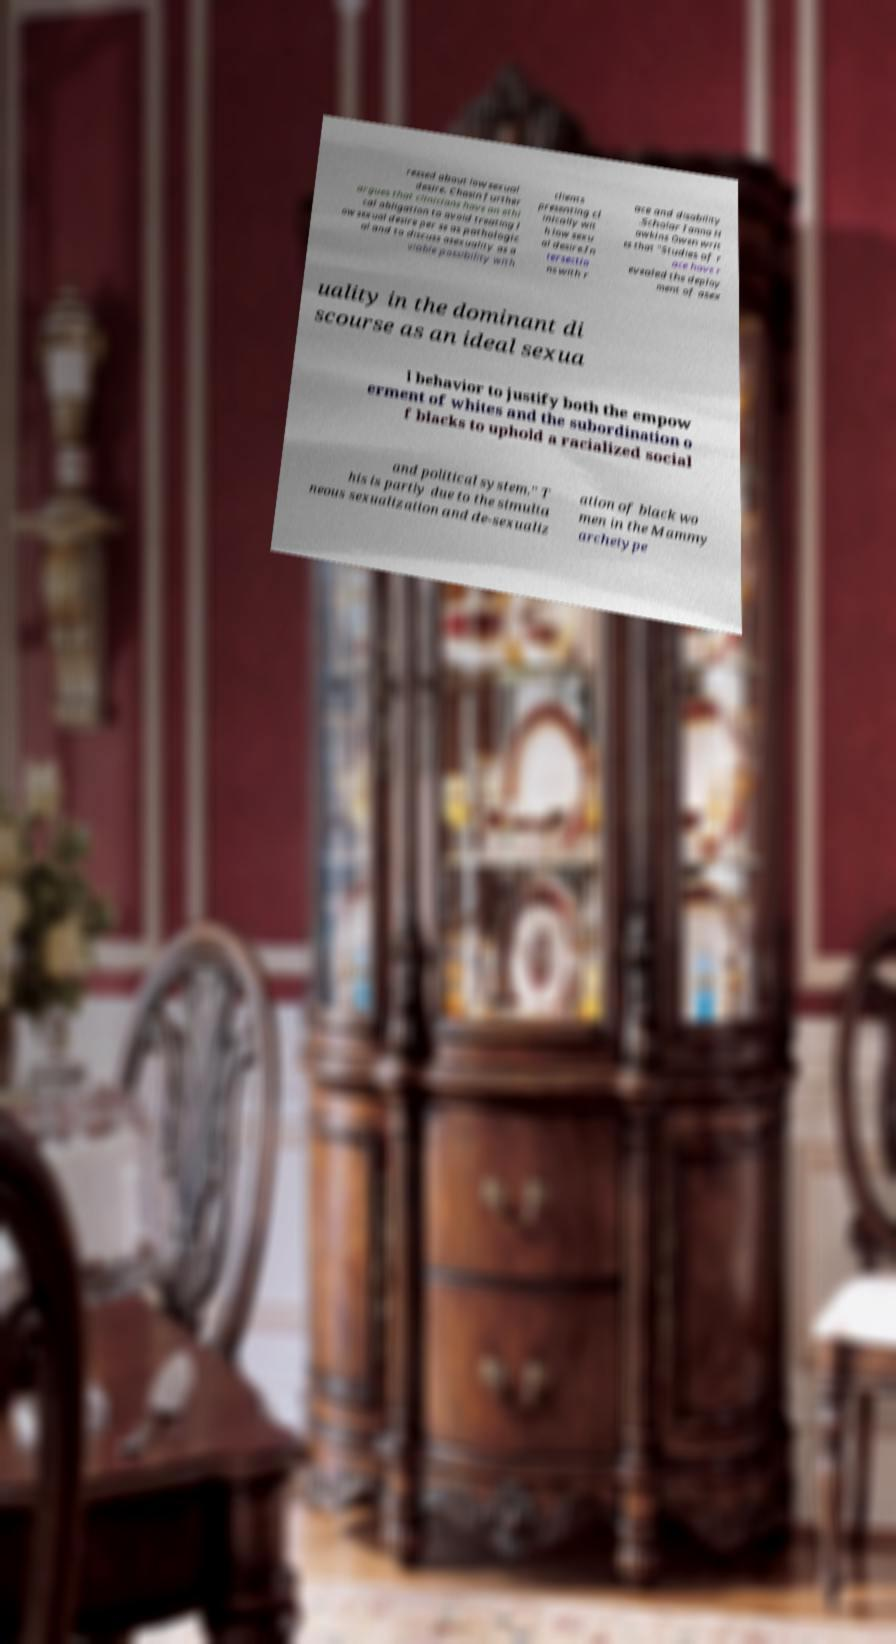What messages or text are displayed in this image? I need them in a readable, typed format. ressed about low sexual desire. Chasin further argues that clinicians have an ethi cal obligation to avoid treating l ow sexual desire per se as pathologic al and to discuss asexuality as a viable possibility with clients presenting cl inically wit h low sexu al desire.In tersectio ns with r ace and disability .Scholar Ianna H awkins Owen writ es that "Studies of r ace have r evealed the deploy ment of asex uality in the dominant di scourse as an ideal sexua l behavior to justify both the empow erment of whites and the subordination o f blacks to uphold a racialized social and political system." T his is partly due to the simulta neous sexualization and de-sexualiz ation of black wo men in the Mammy archetype 